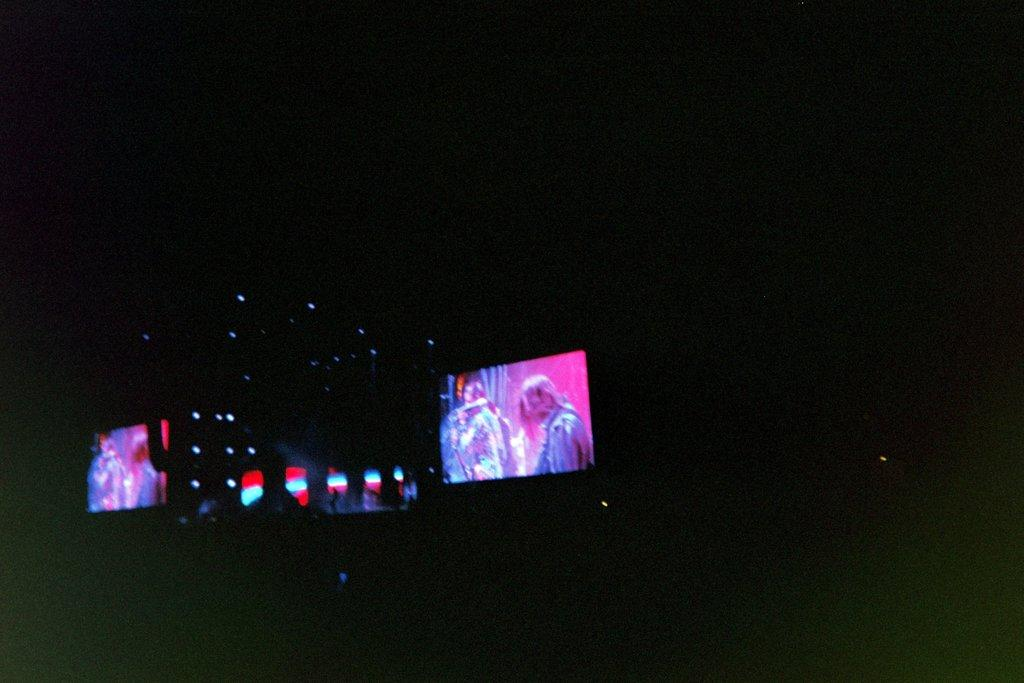What is the main object in the image? There is a screen in the image. What else can be seen in the image besides the screen? There are lights in the image. How would you describe the background behind the screen? The background behind the screen is dark. What type of yoke is attached to the screen in the image? There is no yoke present in the image; it only features a screen and lights. 